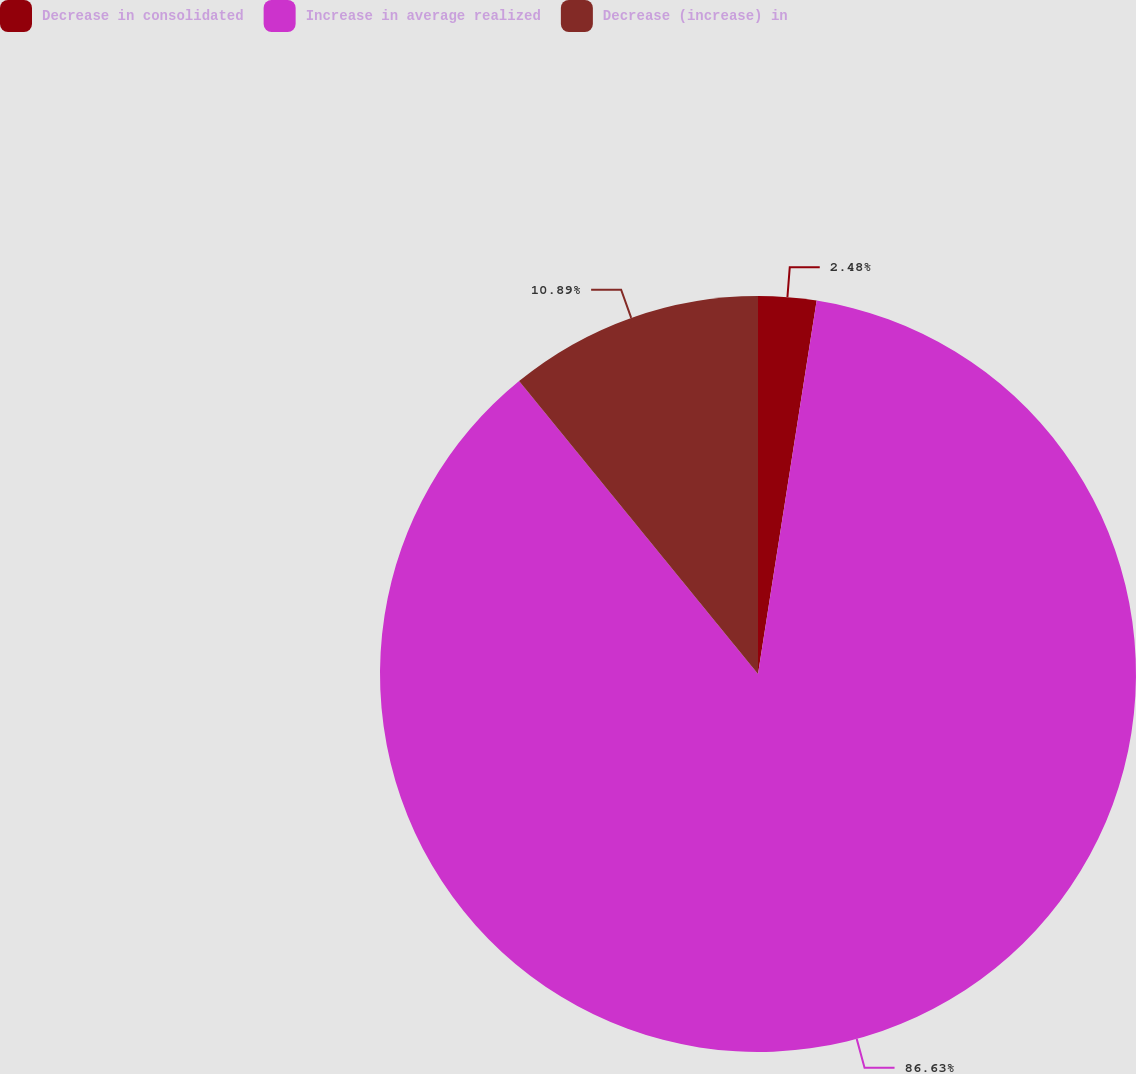<chart> <loc_0><loc_0><loc_500><loc_500><pie_chart><fcel>Decrease in consolidated<fcel>Increase in average realized<fcel>Decrease (increase) in<nl><fcel>2.48%<fcel>86.63%<fcel>10.89%<nl></chart> 